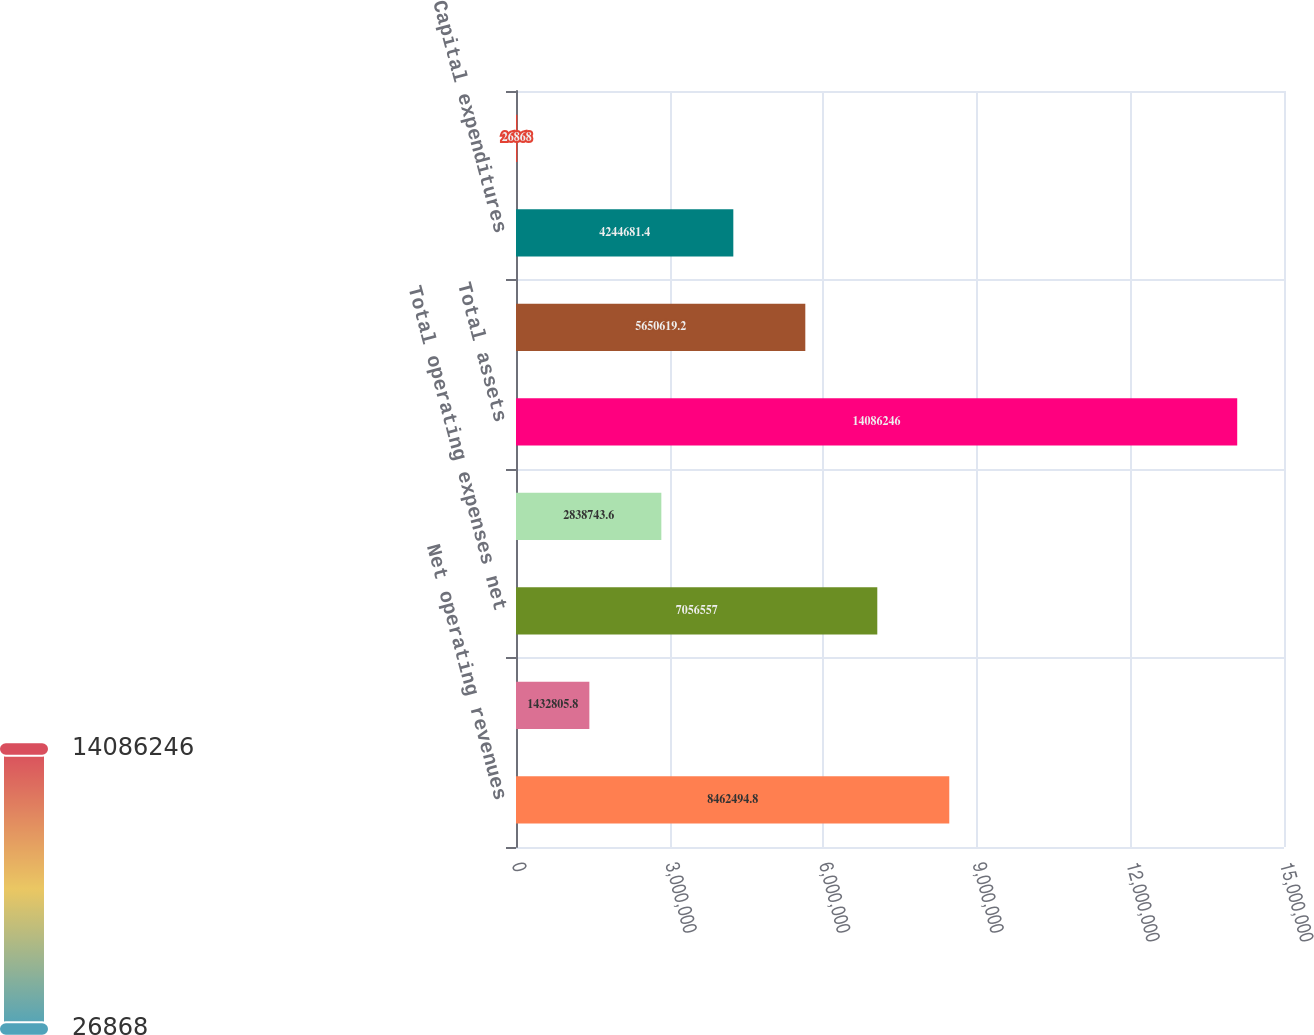Convert chart. <chart><loc_0><loc_0><loc_500><loc_500><bar_chart><fcel>Net operating revenues<fcel>Depreciation and amortization<fcel>Total operating expenses net<fcel>Income from continuing<fcel>Total assets<fcel>Assets of discontinued<fcel>Capital expenditures<fcel>Capital expenditures of<nl><fcel>8.46249e+06<fcel>1.43281e+06<fcel>7.05656e+06<fcel>2.83874e+06<fcel>1.40862e+07<fcel>5.65062e+06<fcel>4.24468e+06<fcel>26868<nl></chart> 